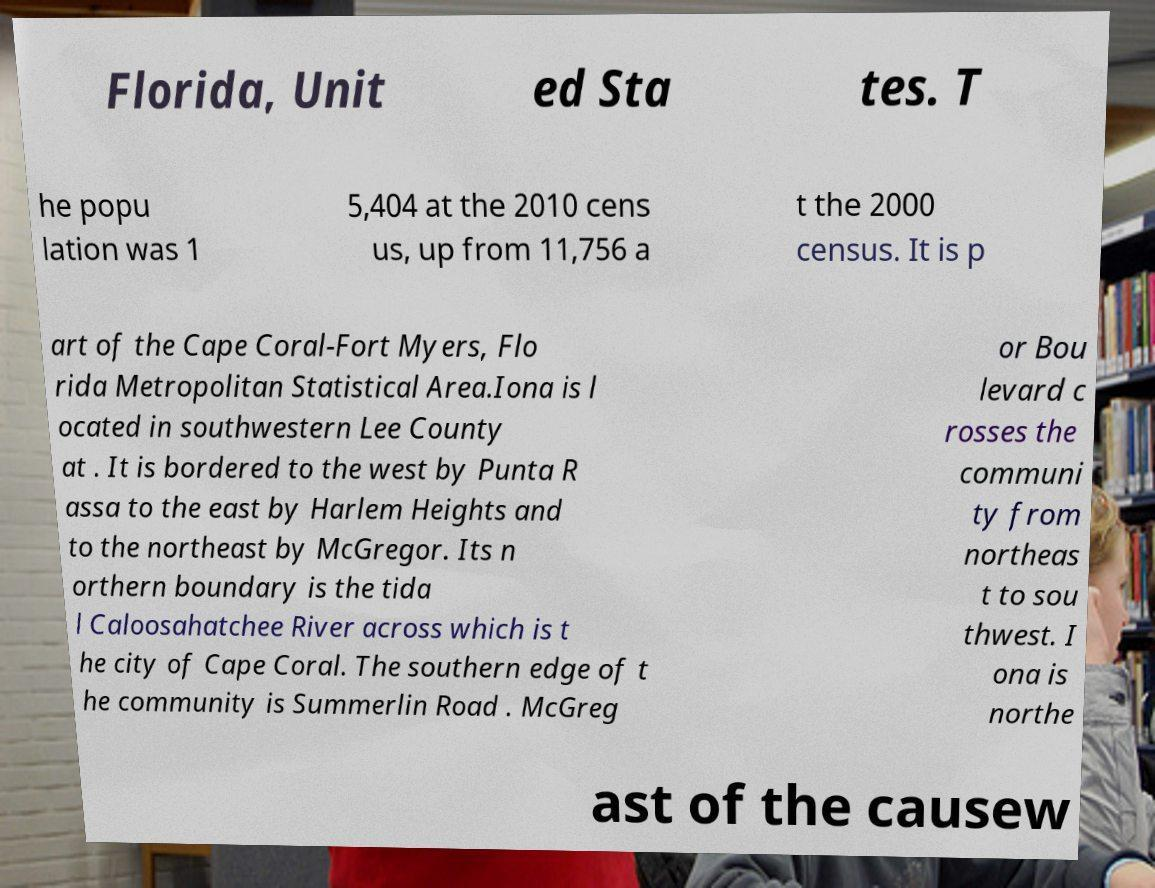I need the written content from this picture converted into text. Can you do that? Florida, Unit ed Sta tes. T he popu lation was 1 5,404 at the 2010 cens us, up from 11,756 a t the 2000 census. It is p art of the Cape Coral-Fort Myers, Flo rida Metropolitan Statistical Area.Iona is l ocated in southwestern Lee County at . It is bordered to the west by Punta R assa to the east by Harlem Heights and to the northeast by McGregor. Its n orthern boundary is the tida l Caloosahatchee River across which is t he city of Cape Coral. The southern edge of t he community is Summerlin Road . McGreg or Bou levard c rosses the communi ty from northeas t to sou thwest. I ona is northe ast of the causew 